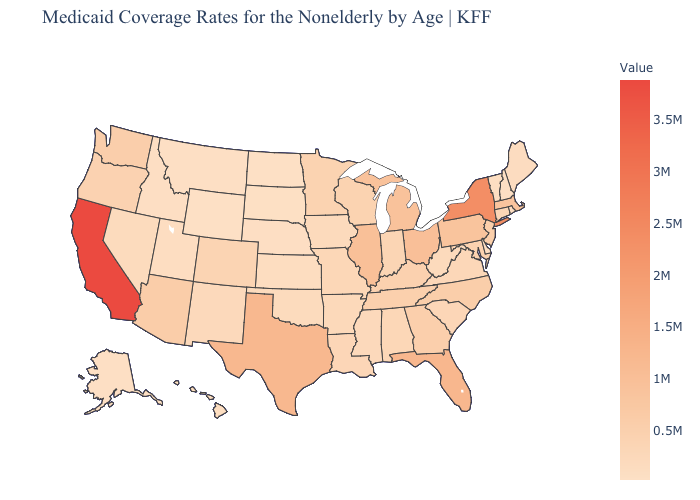Among the states that border Pennsylvania , does New York have the highest value?
Concise answer only. Yes. Does the map have missing data?
Be succinct. No. Does Minnesota have the highest value in the MidWest?
Short answer required. No. 